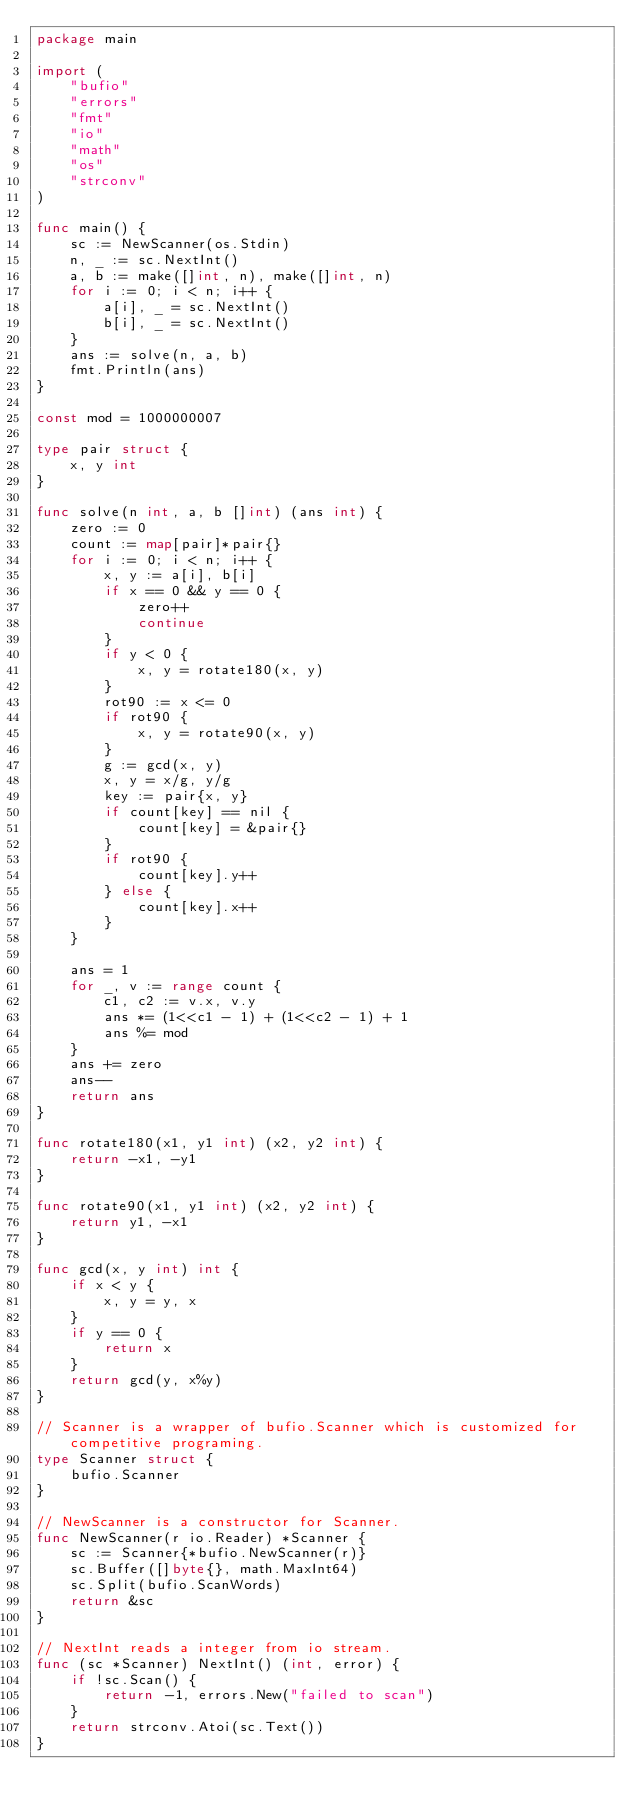Convert code to text. <code><loc_0><loc_0><loc_500><loc_500><_Go_>package main

import (
	"bufio"
	"errors"
	"fmt"
	"io"
	"math"
	"os"
	"strconv"
)

func main() {
	sc := NewScanner(os.Stdin)
	n, _ := sc.NextInt()
	a, b := make([]int, n), make([]int, n)
	for i := 0; i < n; i++ {
		a[i], _ = sc.NextInt()
		b[i], _ = sc.NextInt()
	}
	ans := solve(n, a, b)
	fmt.Println(ans)
}

const mod = 1000000007

type pair struct {
	x, y int
}

func solve(n int, a, b []int) (ans int) {
	zero := 0
	count := map[pair]*pair{}
	for i := 0; i < n; i++ {
		x, y := a[i], b[i]
		if x == 0 && y == 0 {
			zero++
			continue
		}
		if y < 0 {
			x, y = rotate180(x, y)
		}
		rot90 := x <= 0
		if rot90 {
			x, y = rotate90(x, y)
		}
		g := gcd(x, y)
		x, y = x/g, y/g
		key := pair{x, y}
		if count[key] == nil {
			count[key] = &pair{}
		}
		if rot90 {
			count[key].y++
		} else {
			count[key].x++
		}
	}

	ans = 1
	for _, v := range count {
		c1, c2 := v.x, v.y
		ans *= (1<<c1 - 1) + (1<<c2 - 1) + 1
		ans %= mod
	}
	ans += zero
	ans--
	return ans
}

func rotate180(x1, y1 int) (x2, y2 int) {
	return -x1, -y1
}

func rotate90(x1, y1 int) (x2, y2 int) {
	return y1, -x1
}

func gcd(x, y int) int {
	if x < y {
		x, y = y, x
	}
	if y == 0 {
		return x
	}
	return gcd(y, x%y)
}

// Scanner is a wrapper of bufio.Scanner which is customized for competitive programing.
type Scanner struct {
	bufio.Scanner
}

// NewScanner is a constructor for Scanner.
func NewScanner(r io.Reader) *Scanner {
	sc := Scanner{*bufio.NewScanner(r)}
	sc.Buffer([]byte{}, math.MaxInt64)
	sc.Split(bufio.ScanWords)
	return &sc
}

// NextInt reads a integer from io stream.
func (sc *Scanner) NextInt() (int, error) {
	if !sc.Scan() {
		return -1, errors.New("failed to scan")
	}
	return strconv.Atoi(sc.Text())
}
</code> 